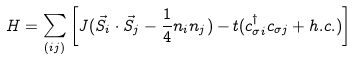<formula> <loc_0><loc_0><loc_500><loc_500>H = \sum _ { ( i j ) } \left [ J ( \vec { S } _ { i } \cdot \vec { S } _ { j } - \frac { 1 } { 4 } n _ { i } n _ { j } ) - t ( c ^ { \dag } _ { \sigma i } c _ { \sigma j } + h . c . ) \right ]</formula> 